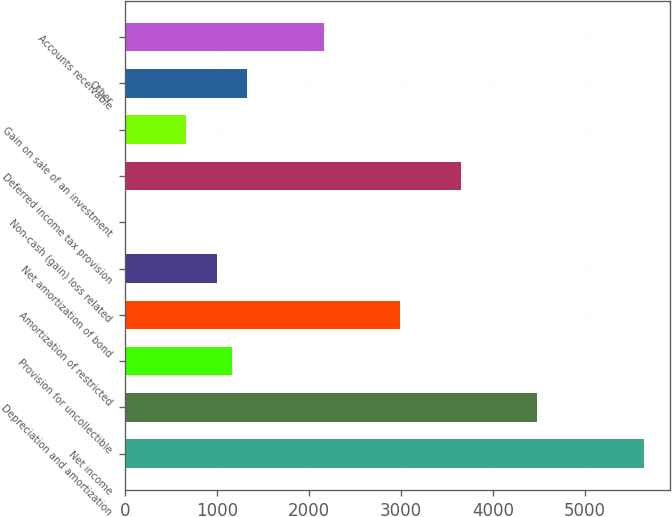<chart> <loc_0><loc_0><loc_500><loc_500><bar_chart><fcel>Net income<fcel>Depreciation and amortization<fcel>Provision for uncollectible<fcel>Amortization of restricted<fcel>Net amortization of bond<fcel>Non-cash (gain) loss related<fcel>Deferred income tax provision<fcel>Gain on sale of an investment<fcel>Other<fcel>Accounts receivable<nl><fcel>5644.84<fcel>4482.77<fcel>1162.57<fcel>2988.68<fcel>996.56<fcel>0.5<fcel>3652.72<fcel>664.54<fcel>1328.58<fcel>2158.63<nl></chart> 